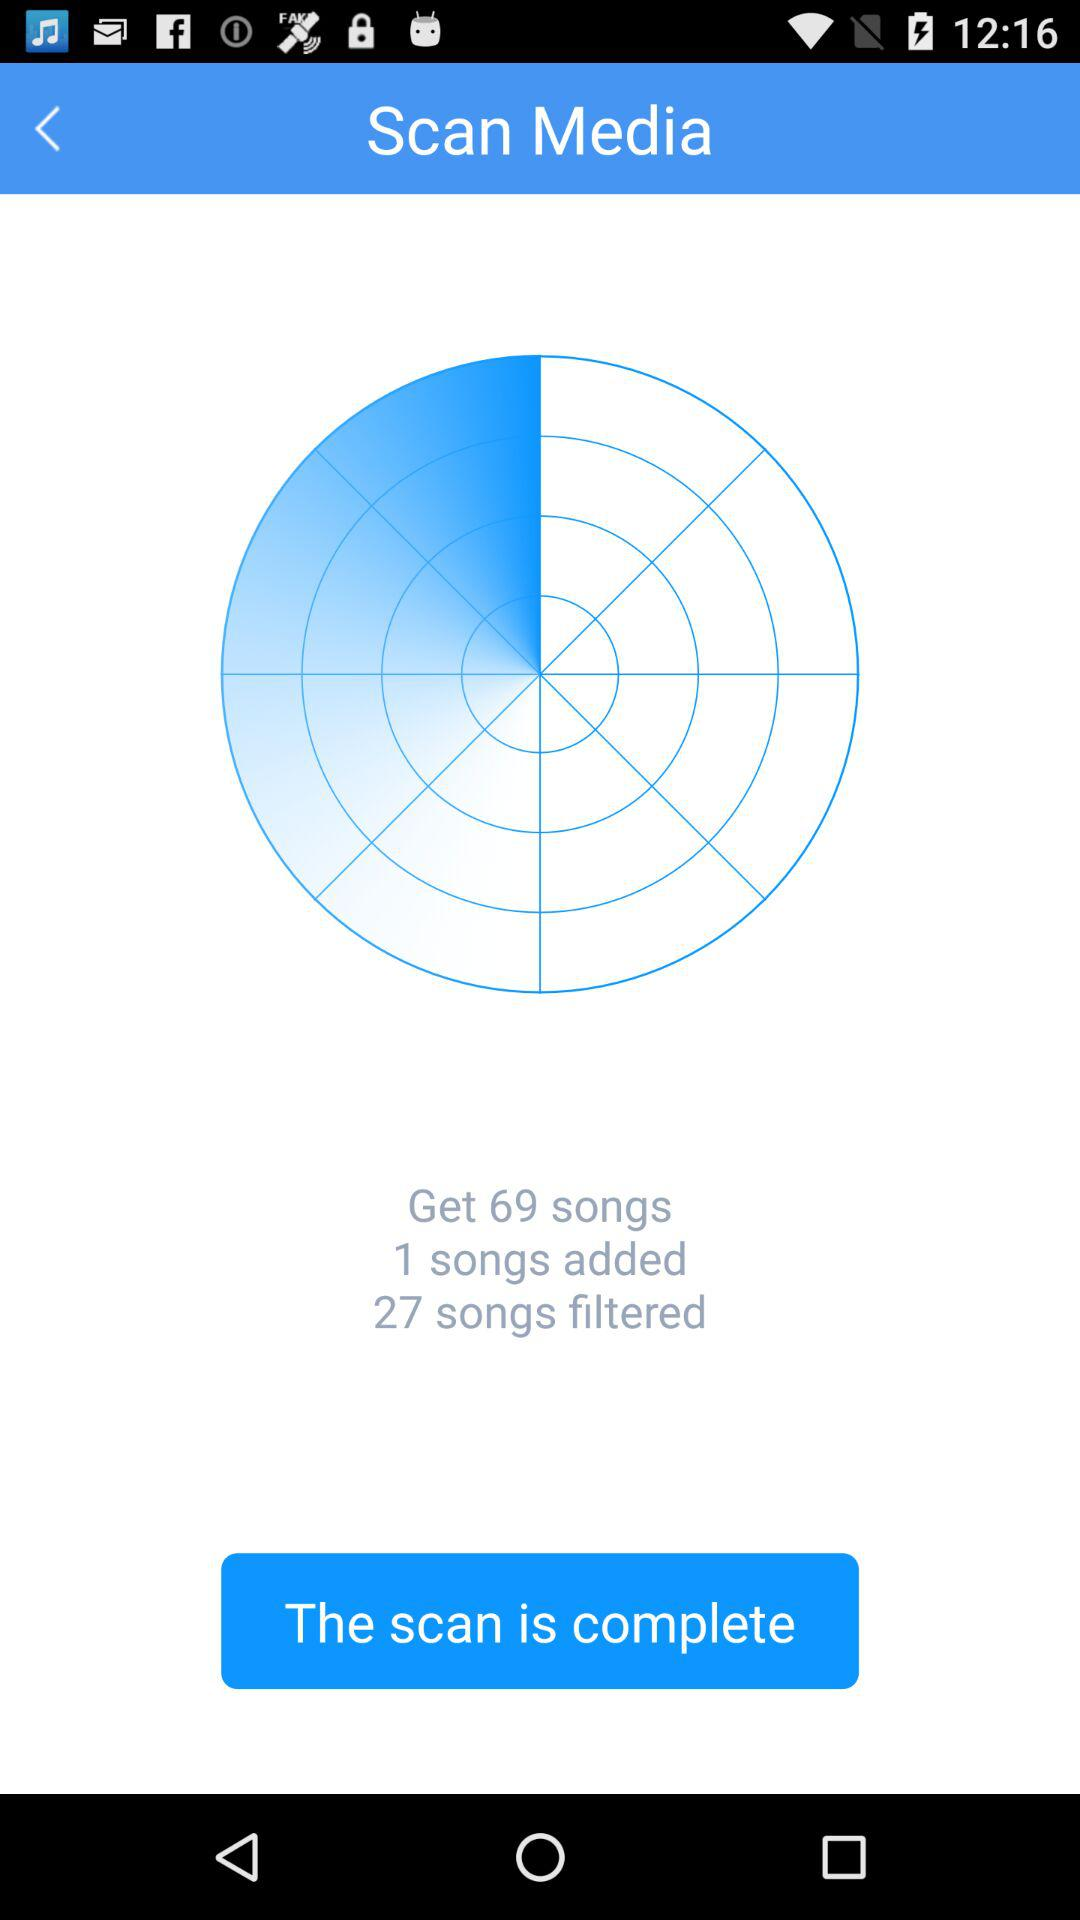How many songs were added to the library?
Answer the question using a single word or phrase. 1 